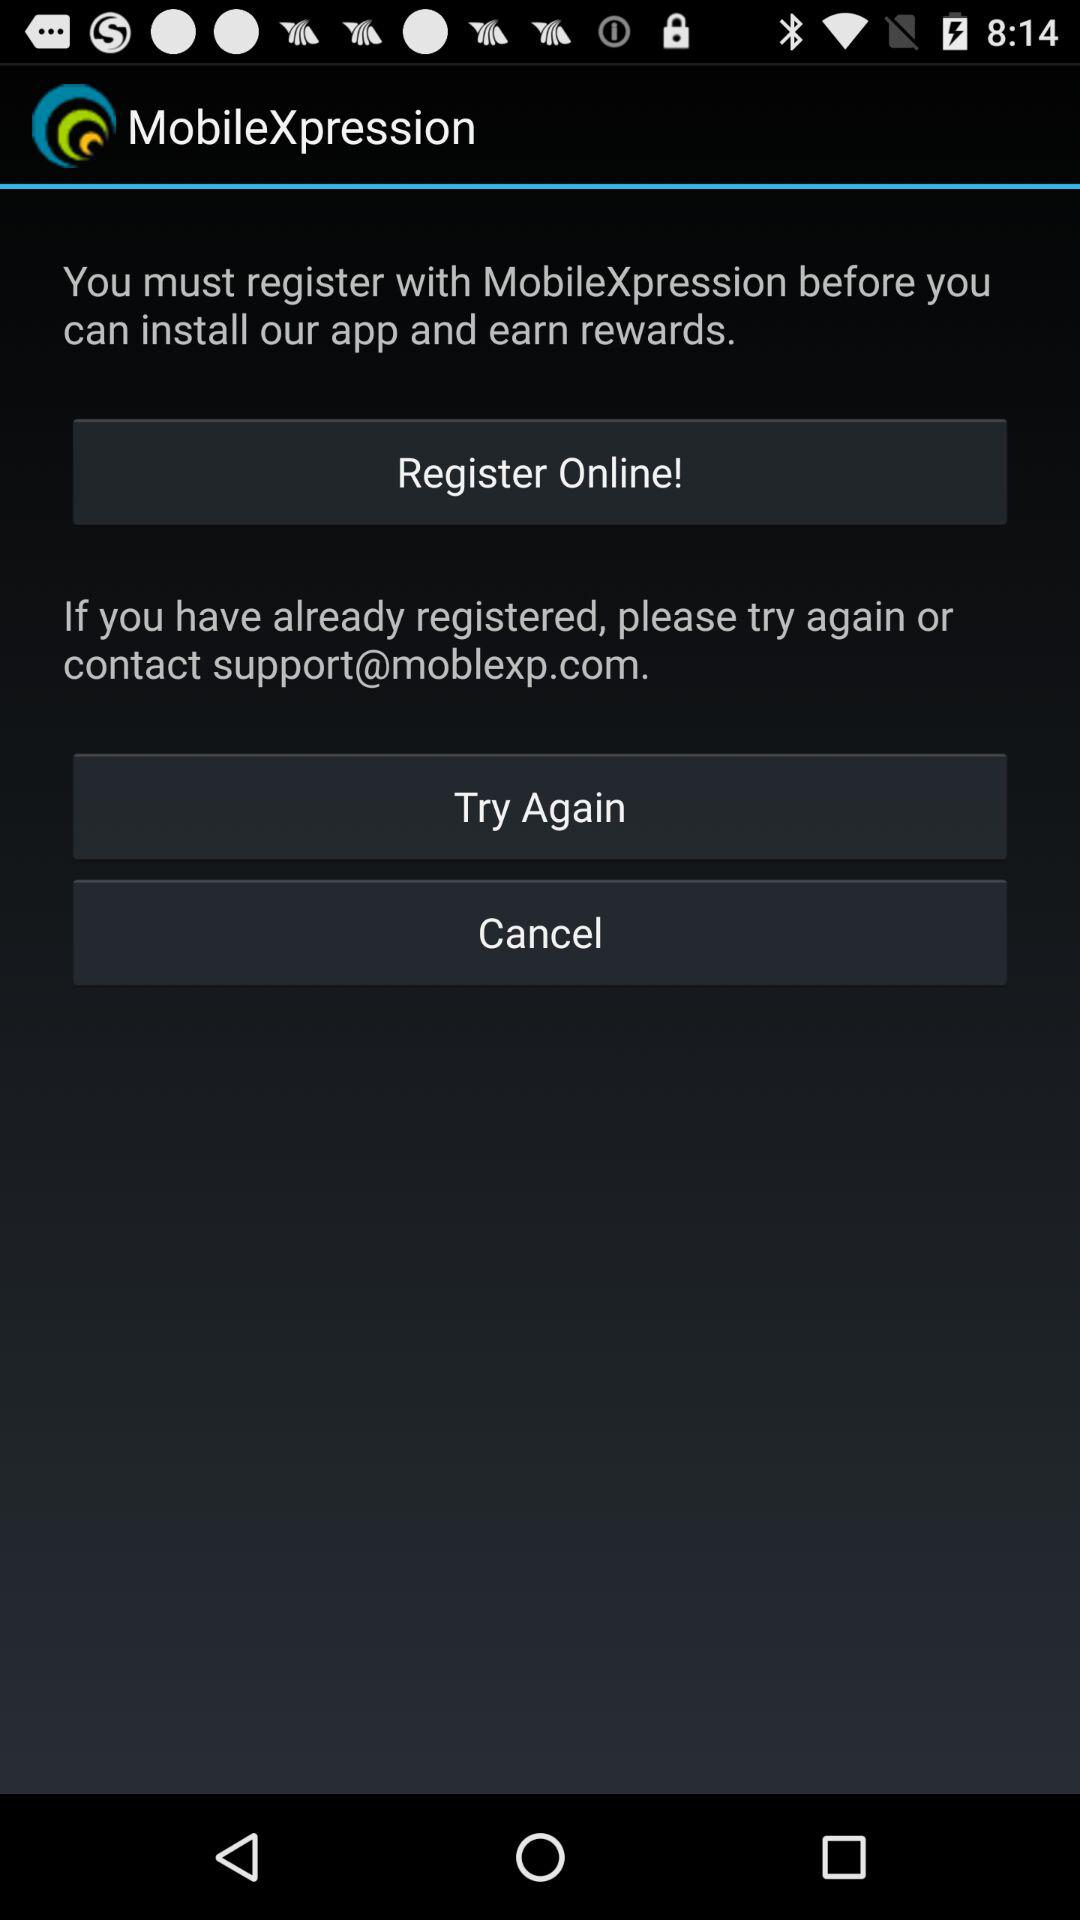What is the application name? The application name is "MobileXpression". 